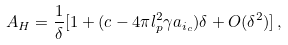Convert formula to latex. <formula><loc_0><loc_0><loc_500><loc_500>A _ { H } = \frac { 1 } { \delta } [ 1 + ( c - 4 \pi l _ { p } ^ { 2 } \gamma a _ { i _ { c } } ) \delta + O ( \delta ^ { 2 } ) ] \, ,</formula> 